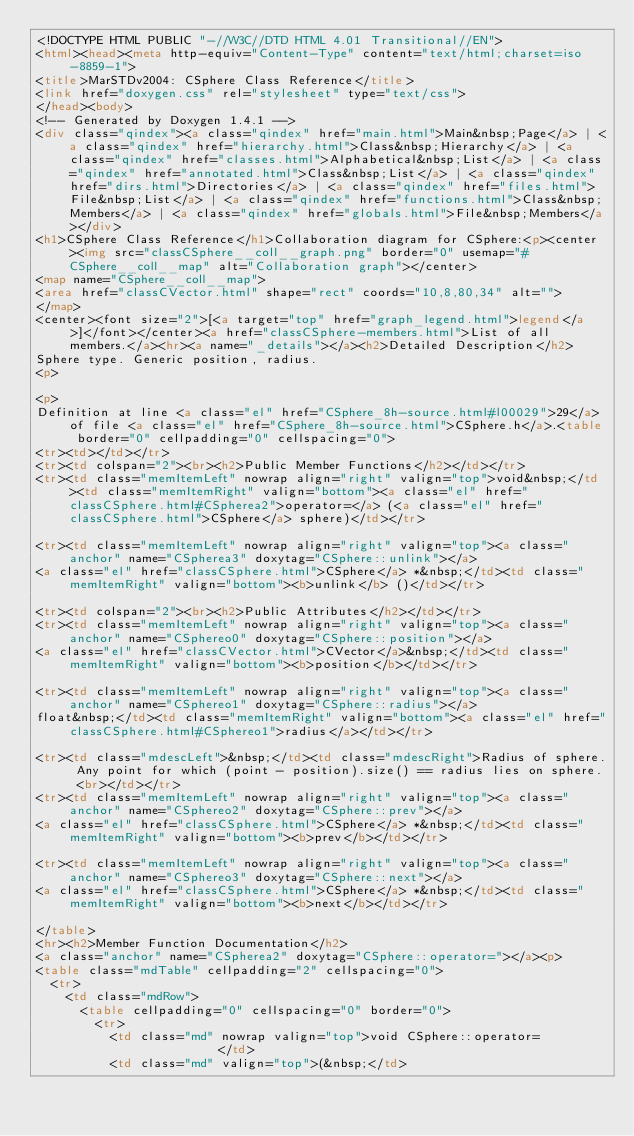Convert code to text. <code><loc_0><loc_0><loc_500><loc_500><_HTML_><!DOCTYPE HTML PUBLIC "-//W3C//DTD HTML 4.01 Transitional//EN">
<html><head><meta http-equiv="Content-Type" content="text/html;charset=iso-8859-1">
<title>MarSTDv2004: CSphere Class Reference</title>
<link href="doxygen.css" rel="stylesheet" type="text/css">
</head><body>
<!-- Generated by Doxygen 1.4.1 -->
<div class="qindex"><a class="qindex" href="main.html">Main&nbsp;Page</a> | <a class="qindex" href="hierarchy.html">Class&nbsp;Hierarchy</a> | <a class="qindex" href="classes.html">Alphabetical&nbsp;List</a> | <a class="qindex" href="annotated.html">Class&nbsp;List</a> | <a class="qindex" href="dirs.html">Directories</a> | <a class="qindex" href="files.html">File&nbsp;List</a> | <a class="qindex" href="functions.html">Class&nbsp;Members</a> | <a class="qindex" href="globals.html">File&nbsp;Members</a></div>
<h1>CSphere Class Reference</h1>Collaboration diagram for CSphere:<p><center><img src="classCSphere__coll__graph.png" border="0" usemap="#CSphere__coll__map" alt="Collaboration graph"></center>
<map name="CSphere__coll__map">
<area href="classCVector.html" shape="rect" coords="10,8,80,34" alt="">
</map>
<center><font size="2">[<a target="top" href="graph_legend.html">legend</a>]</font></center><a href="classCSphere-members.html">List of all members.</a><hr><a name="_details"></a><h2>Detailed Description</h2>
Sphere type. Generic position, radius. 
<p>

<p>
Definition at line <a class="el" href="CSphere_8h-source.html#l00029">29</a> of file <a class="el" href="CSphere_8h-source.html">CSphere.h</a>.<table border="0" cellpadding="0" cellspacing="0">
<tr><td></td></tr>
<tr><td colspan="2"><br><h2>Public Member Functions</h2></td></tr>
<tr><td class="memItemLeft" nowrap align="right" valign="top">void&nbsp;</td><td class="memItemRight" valign="bottom"><a class="el" href="classCSphere.html#CSpherea2">operator=</a> (<a class="el" href="classCSphere.html">CSphere</a> sphere)</td></tr>

<tr><td class="memItemLeft" nowrap align="right" valign="top"><a class="anchor" name="CSpherea3" doxytag="CSphere::unlink"></a>
<a class="el" href="classCSphere.html">CSphere</a> *&nbsp;</td><td class="memItemRight" valign="bottom"><b>unlink</b> ()</td></tr>

<tr><td colspan="2"><br><h2>Public Attributes</h2></td></tr>
<tr><td class="memItemLeft" nowrap align="right" valign="top"><a class="anchor" name="CSphereo0" doxytag="CSphere::position"></a>
<a class="el" href="classCVector.html">CVector</a>&nbsp;</td><td class="memItemRight" valign="bottom"><b>position</b></td></tr>

<tr><td class="memItemLeft" nowrap align="right" valign="top"><a class="anchor" name="CSphereo1" doxytag="CSphere::radius"></a>
float&nbsp;</td><td class="memItemRight" valign="bottom"><a class="el" href="classCSphere.html#CSphereo1">radius</a></td></tr>

<tr><td class="mdescLeft">&nbsp;</td><td class="mdescRight">Radius of sphere. Any point for which (point - position).size() == radius lies on sphere. <br></td></tr>
<tr><td class="memItemLeft" nowrap align="right" valign="top"><a class="anchor" name="CSphereo2" doxytag="CSphere::prev"></a>
<a class="el" href="classCSphere.html">CSphere</a> *&nbsp;</td><td class="memItemRight" valign="bottom"><b>prev</b></td></tr>

<tr><td class="memItemLeft" nowrap align="right" valign="top"><a class="anchor" name="CSphereo3" doxytag="CSphere::next"></a>
<a class="el" href="classCSphere.html">CSphere</a> *&nbsp;</td><td class="memItemRight" valign="bottom"><b>next</b></td></tr>

</table>
<hr><h2>Member Function Documentation</h2>
<a class="anchor" name="CSpherea2" doxytag="CSphere::operator="></a><p>
<table class="mdTable" cellpadding="2" cellspacing="0">
  <tr>
    <td class="mdRow">
      <table cellpadding="0" cellspacing="0" border="0">
        <tr>
          <td class="md" nowrap valign="top">void CSphere::operator=           </td>
          <td class="md" valign="top">(&nbsp;</td></code> 